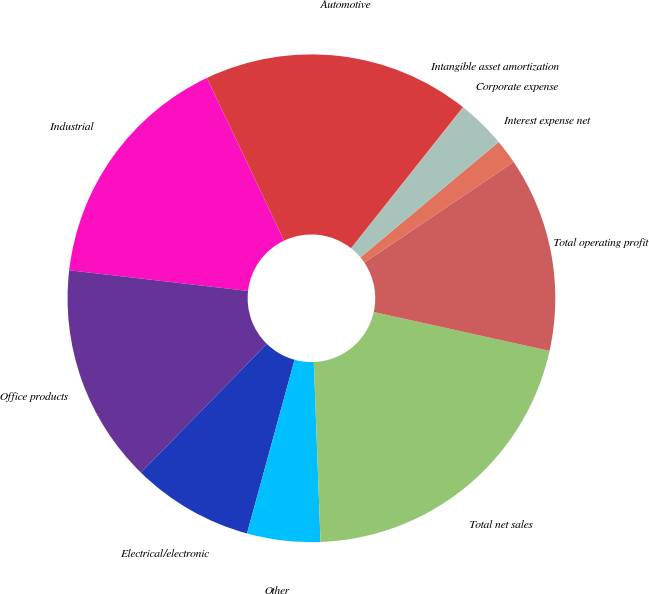Convert chart to OTSL. <chart><loc_0><loc_0><loc_500><loc_500><pie_chart><fcel>Automotive<fcel>Industrial<fcel>Office products<fcel>Electrical/electronic<fcel>Other<fcel>Total net sales<fcel>Total operating profit<fcel>Interest expense net<fcel>Corporate expense<fcel>Intangible asset amortization<nl><fcel>17.73%<fcel>16.12%<fcel>14.51%<fcel>8.07%<fcel>4.85%<fcel>20.95%<fcel>12.9%<fcel>1.63%<fcel>3.24%<fcel>0.02%<nl></chart> 